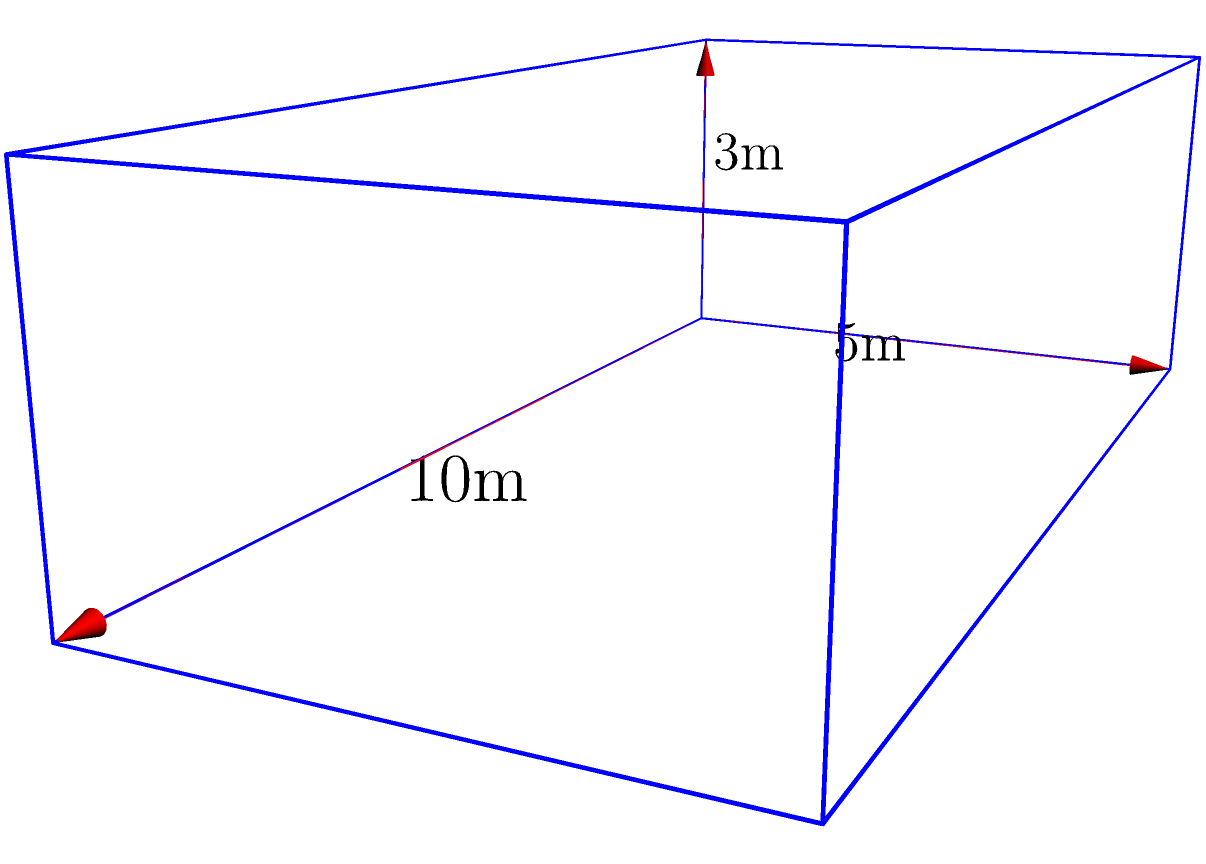A rectangular underground bunker is being planned for a strategic military operation. The bunker's dimensions are 10 meters in length, 5 meters in width, and 3 meters in height. What is the total volume of this bunker in cubic meters? To calculate the volume of a rectangular bunker, we need to multiply its length, width, and height.

Step 1: Identify the dimensions
Length (l) = 10 meters
Width (w) = 5 meters
Height (h) = 3 meters

Step 2: Apply the formula for the volume of a rectangular prism
Volume = length × width × height
$$V = l \times w \times h$$

Step 3: Substitute the values and calculate
$$V = 10 \text{ m} \times 5 \text{ m} \times 3 \text{ m}$$
$$V = 150 \text{ m}^3$$

Therefore, the total volume of the rectangular bunker is 150 cubic meters.
Answer: 150 m³ 